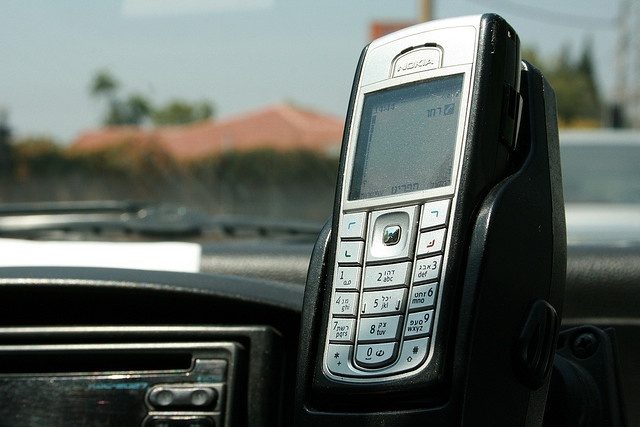Describe the objects in this image and their specific colors. I can see cell phone in lightblue, white, gray, black, and darkgray tones and car in lightblue, gray, darkgray, and lightgray tones in this image. 